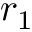Convert formula to latex. <formula><loc_0><loc_0><loc_500><loc_500>r _ { 1 }</formula> 